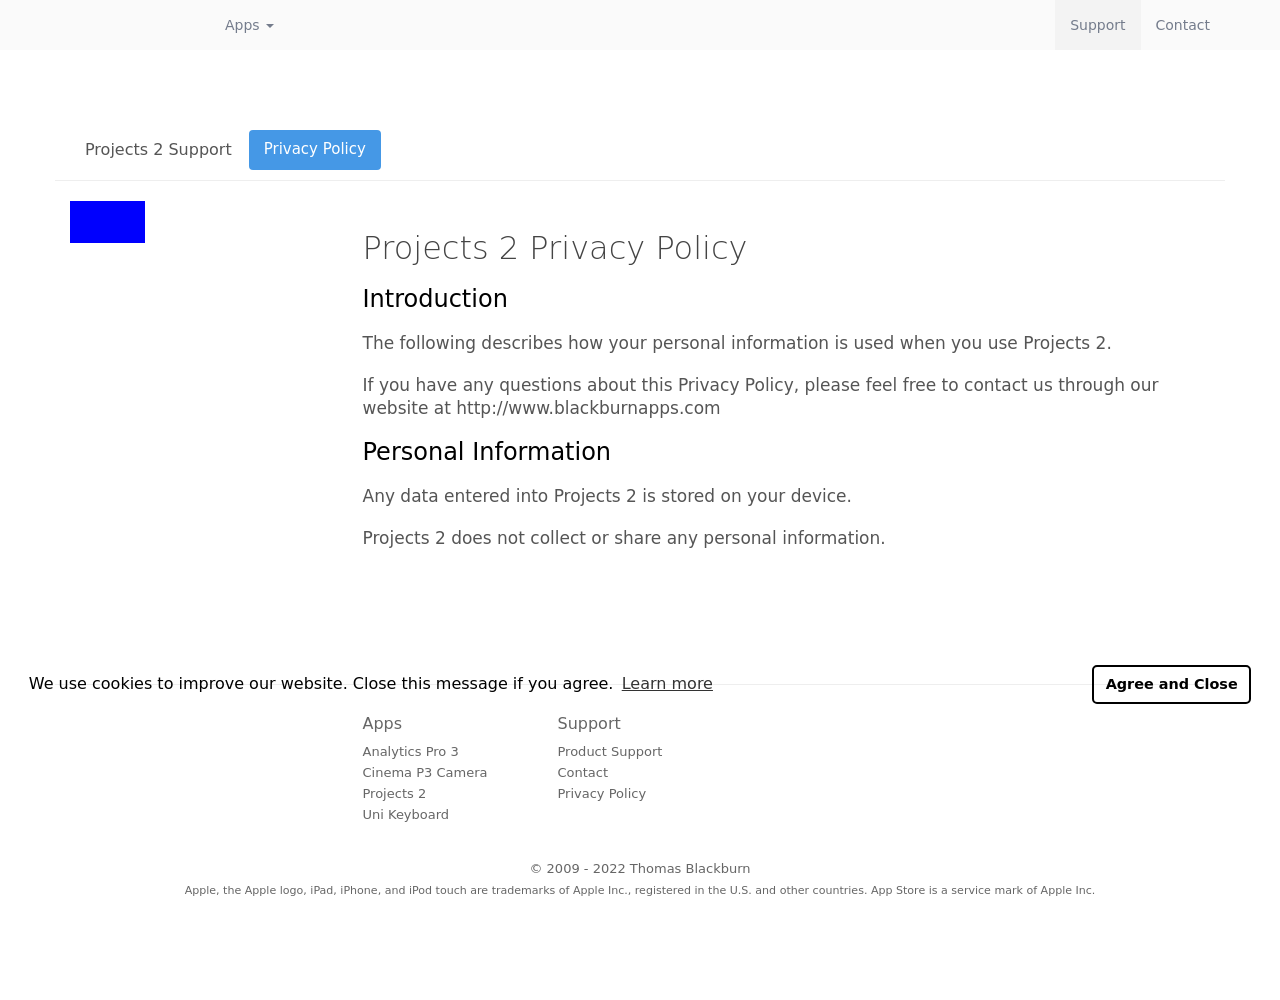Could you detail the process for assembling this website using HTML? To build a website similar to the one shown in the image, you would begin by structuring your HTML to create a clean layout. Start with defining a DOCTYPE and the structure of your HTML, including the head and body sections. Inside the head, include meta tags for responsiveness and character set. Use link tags for CSS stylesheets to ensure the aesthetic matches the professional tone of the site. In the body, use a navigation bar perhaps with dropdown menus for multi-tier navigation, employing div containers and appropriate classes to style the components. Utilize paragraphs for text sections and anchor tags for clickable links, ensuring all parts are cohesively styled with external or internal CSS for a polished look. 